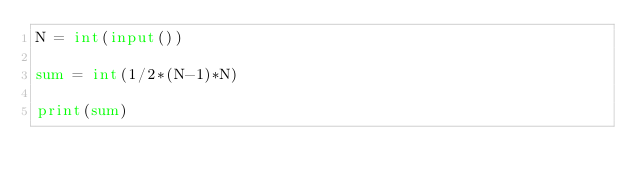Convert code to text. <code><loc_0><loc_0><loc_500><loc_500><_Python_>N = int(input())

sum = int(1/2*(N-1)*N)

print(sum)
</code> 